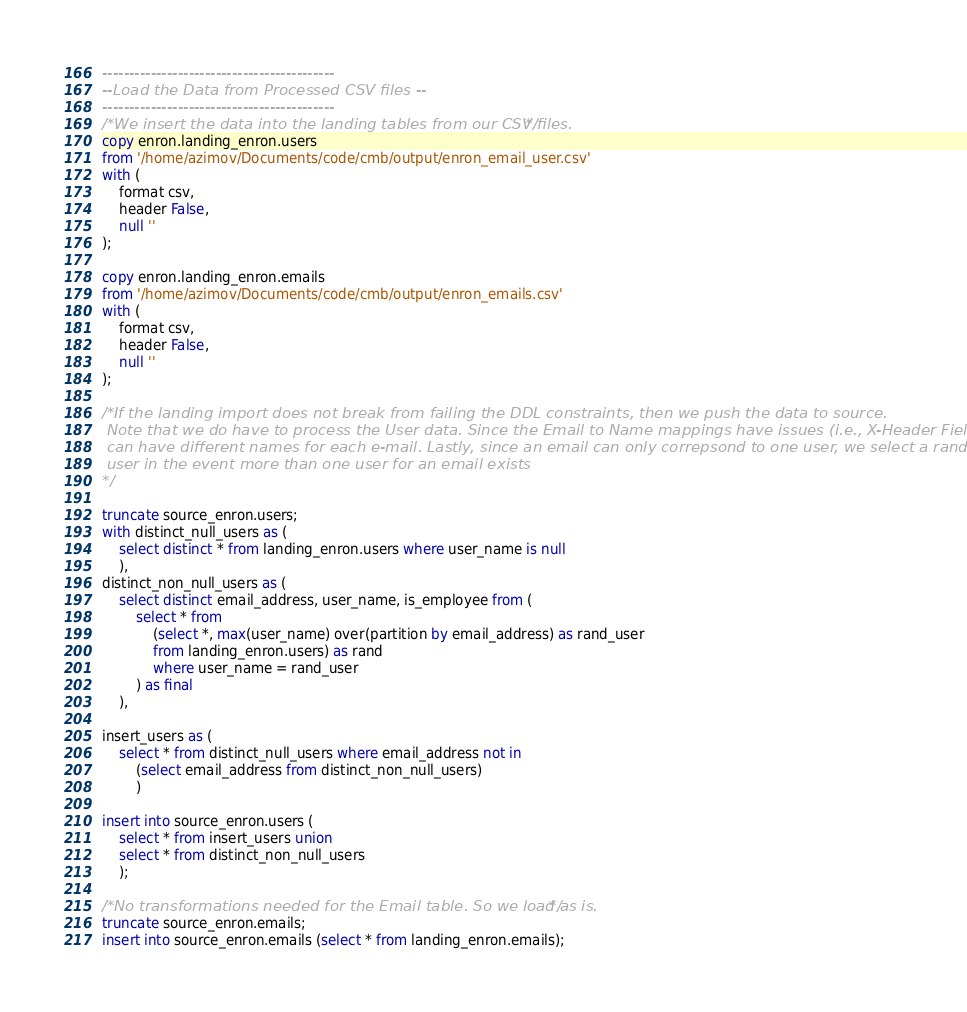Convert code to text. <code><loc_0><loc_0><loc_500><loc_500><_SQL_>-------------------------------------------
--Load the Data from Processed CSV files --
-------------------------------------------
/*We insert the data into the landing tables from our CSV files.*/
copy enron.landing_enron.users 
from '/home/azimov/Documents/code/cmb/output/enron_email_user.csv'
with (
	format csv,
	header False,
	null ''
);

copy enron.landing_enron.emails 
from '/home/azimov/Documents/code/cmb/output/enron_emails.csv'
with (
	format csv,
	header False,
	null ''
);

/*If the landing import does not break from failing the DDL constraints, then we push the data to source.
 Note that we do have to process the User data. Since the Email to Name mappings have issues (i.e., X-Header Fields
 can have different names for each e-mail. Lastly, since an email can only correpsond to one user, we select a random
 user in the event more than one user for an email exists
*/

truncate source_enron.users;
with distinct_null_users as (
	select distinct * from landing_enron.users where user_name is null
	),
distinct_non_null_users as (
	select distinct email_address, user_name, is_employee from (
		select * from 
			(select *, max(user_name) over(partition by email_address) as rand_user
			from landing_enron.users) as rand 
			where user_name = rand_user
		) as final
	),
	
insert_users as (
	select * from distinct_null_users where email_address not in
		(select email_address from distinct_non_null_users)
		)

insert into source_enron.users (
	select * from insert_users union
	select * from distinct_non_null_users
	);

/*No transformations needed for the Email table. So we load as is.*/
truncate source_enron.emails;
insert into source_enron.emails (select * from landing_enron.emails);</code> 